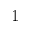Convert formula to latex. <formula><loc_0><loc_0><loc_500><loc_500>1</formula> 